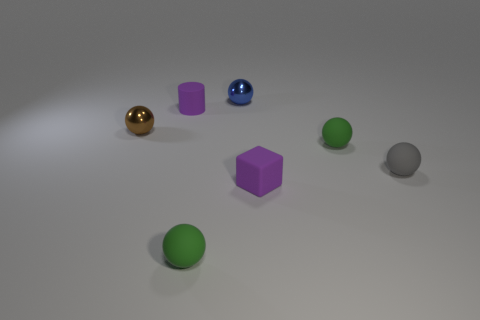Is the size of the gray ball the same as the block?
Offer a terse response. Yes. How many purple matte objects are both to the left of the blue metal ball and in front of the brown shiny object?
Offer a very short reply. 0. There is a purple rubber object in front of the tiny metal ball left of the purple cylinder; is there a purple matte block that is behind it?
Ensure brevity in your answer.  No. There is a blue object that is the same size as the purple block; what shape is it?
Provide a succinct answer. Sphere. Are there any large rubber things that have the same color as the small cylinder?
Your answer should be very brief. No. What number of big things are blue matte cylinders or rubber cubes?
Ensure brevity in your answer.  0. The cylinder that is the same material as the small gray sphere is what color?
Provide a short and direct response. Purple. How many purple objects have the same material as the tiny gray sphere?
Make the answer very short. 2. What material is the tiny purple object that is in front of the small purple object on the left side of the small blue metal sphere?
Your answer should be very brief. Rubber. Are there fewer small blue balls on the right side of the tiny gray thing than tiny purple matte objects that are in front of the brown metal ball?
Your answer should be compact. Yes. 